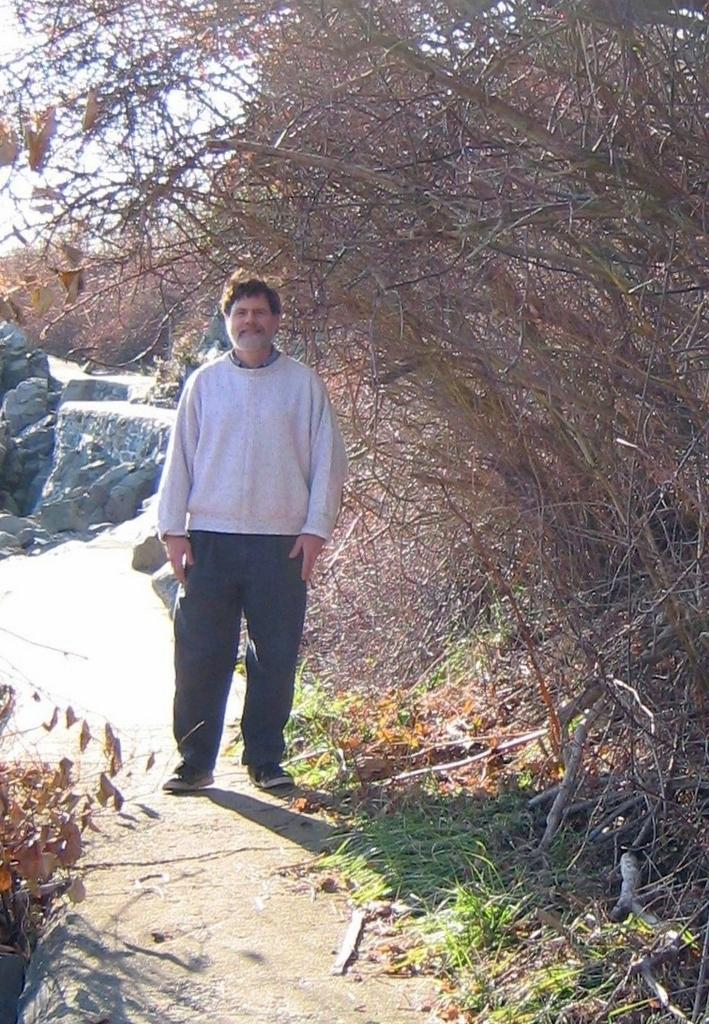What is the main subject of the image? There is a man in the image. Can you describe the man's clothing? The man is wearing a t-shirt, trousers, and shoes. What type of natural environment is visible in the image? There are trees, plants, grass, and stones in the image. What part of the sky is visible in the image? The sky is visible in the image. What type of regret can be seen on the man's face in the image? There is no indication of regret on the man's face in the image. Can you tell me how many pigs are present in the image? There are no pigs present in the image. What type of kettle is visible in the image? There is no kettle present in the image. 